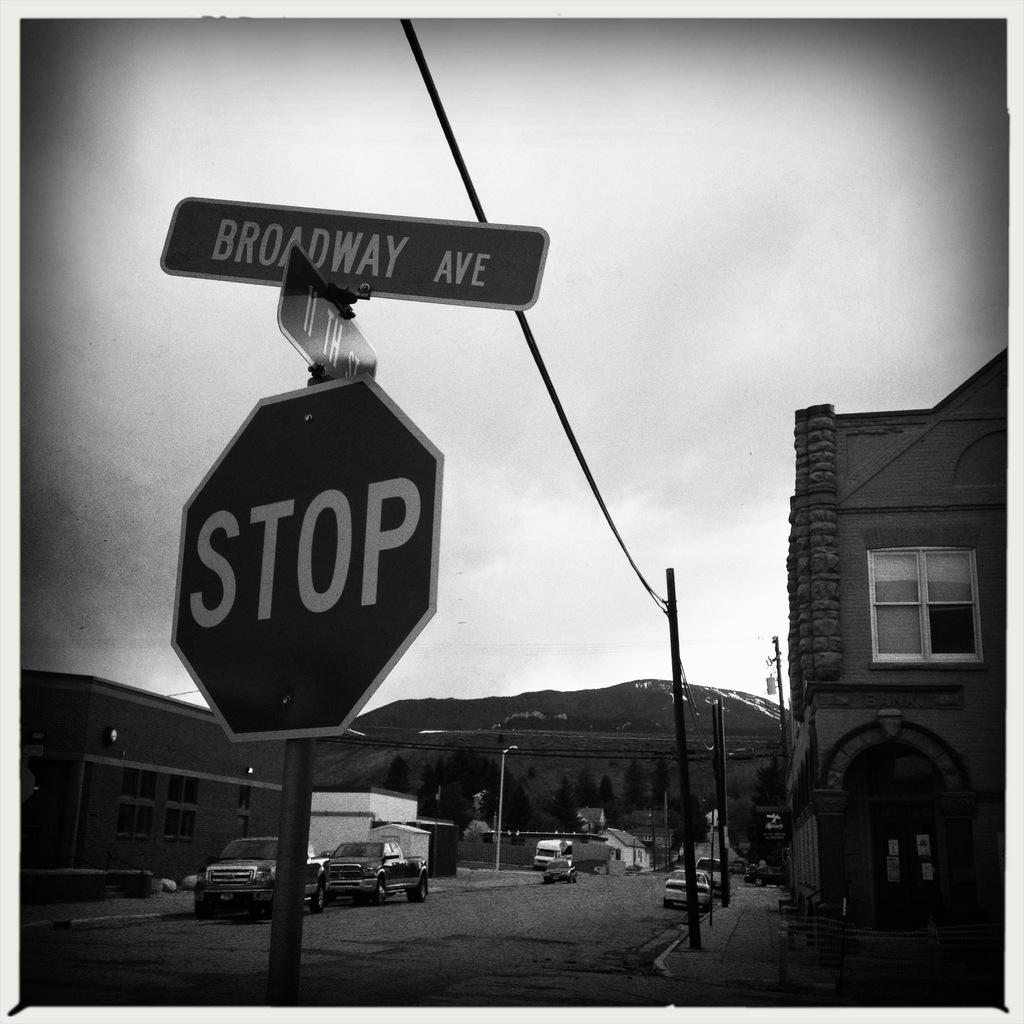Provide a one-sentence caption for the provided image. stop sign and street sign placed in the street. 